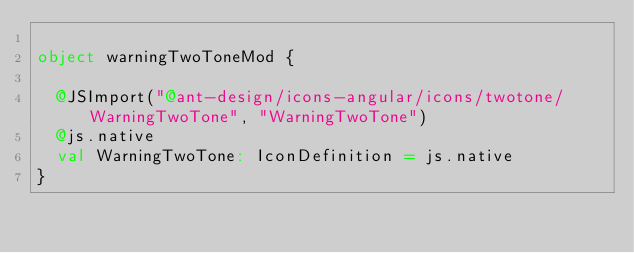<code> <loc_0><loc_0><loc_500><loc_500><_Scala_>
object warningTwoToneMod {
  
  @JSImport("@ant-design/icons-angular/icons/twotone/WarningTwoTone", "WarningTwoTone")
  @js.native
  val WarningTwoTone: IconDefinition = js.native
}
</code> 